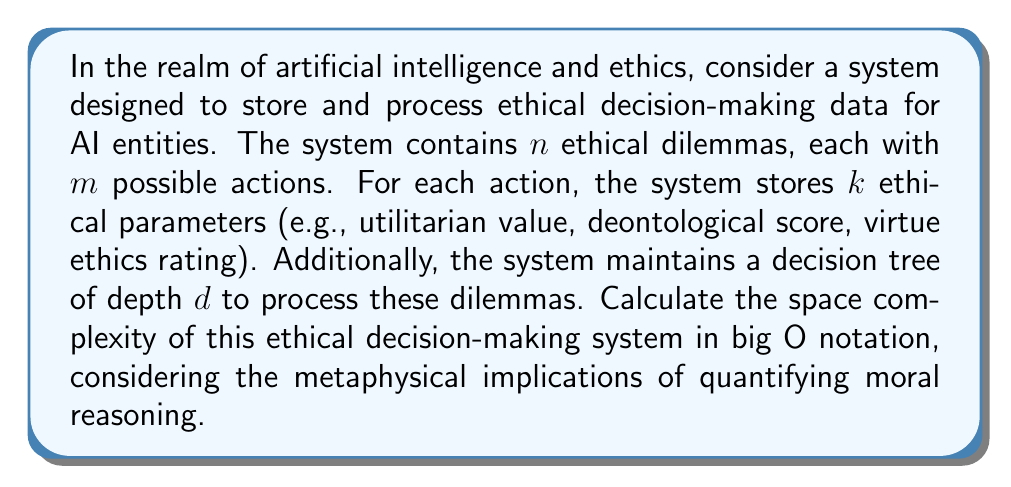Can you solve this math problem? To determine the space complexity of this ethical decision-making system, we need to consider the storage requirements for each component:

1. Ethical dilemmas storage:
   - There are $n$ dilemmas, each with $m$ possible actions
   - For each action, we store $k$ ethical parameters
   - Space required: $O(n \cdot m \cdot k)$

2. Decision tree storage:
   - The decision tree has a depth of $d$
   - In a binary decision tree, the maximum number of nodes is $2^{d+1} - 1$
   - Space required for the tree structure: $O(2^d)$

3. Additional metadata:
   - We may need to store some constant amount of metadata for each dilemma and the overall system
   - This would be $O(n)$ for dilemma-specific metadata and $O(1)$ for system-wide metadata

Combining these components, the total space complexity is:

$$O(n \cdot m \cdot k + 2^d + n + 1)$$

Simplifying this expression:
- The constant term $O(1)$ can be dropped as it's insignificant for large inputs
- $O(n)$ is dominated by $O(n \cdot m \cdot k)$ since $m$ and $k$ are always $\geq 1$
- The final space complexity depends on the relative sizes of $n \cdot m \cdot k$ and $2^d$

Therefore, the space complexity can be expressed as:

$$O(\max(n \cdot m \cdot k, 2^d))$$

From a metaphysical perspective, this quantification of ethical decision-making raises questions about the nature of moral reasoning and whether it can be fully captured in a finite computational space. The exponential growth of the decision tree ($2^d$) might suggest that truly comprehensive ethical reasoning could quickly become computationally intractable, reflecting the complex and often unbounded nature of moral philosophy.
Answer: $O(\max(n \cdot m \cdot k, 2^d))$ 